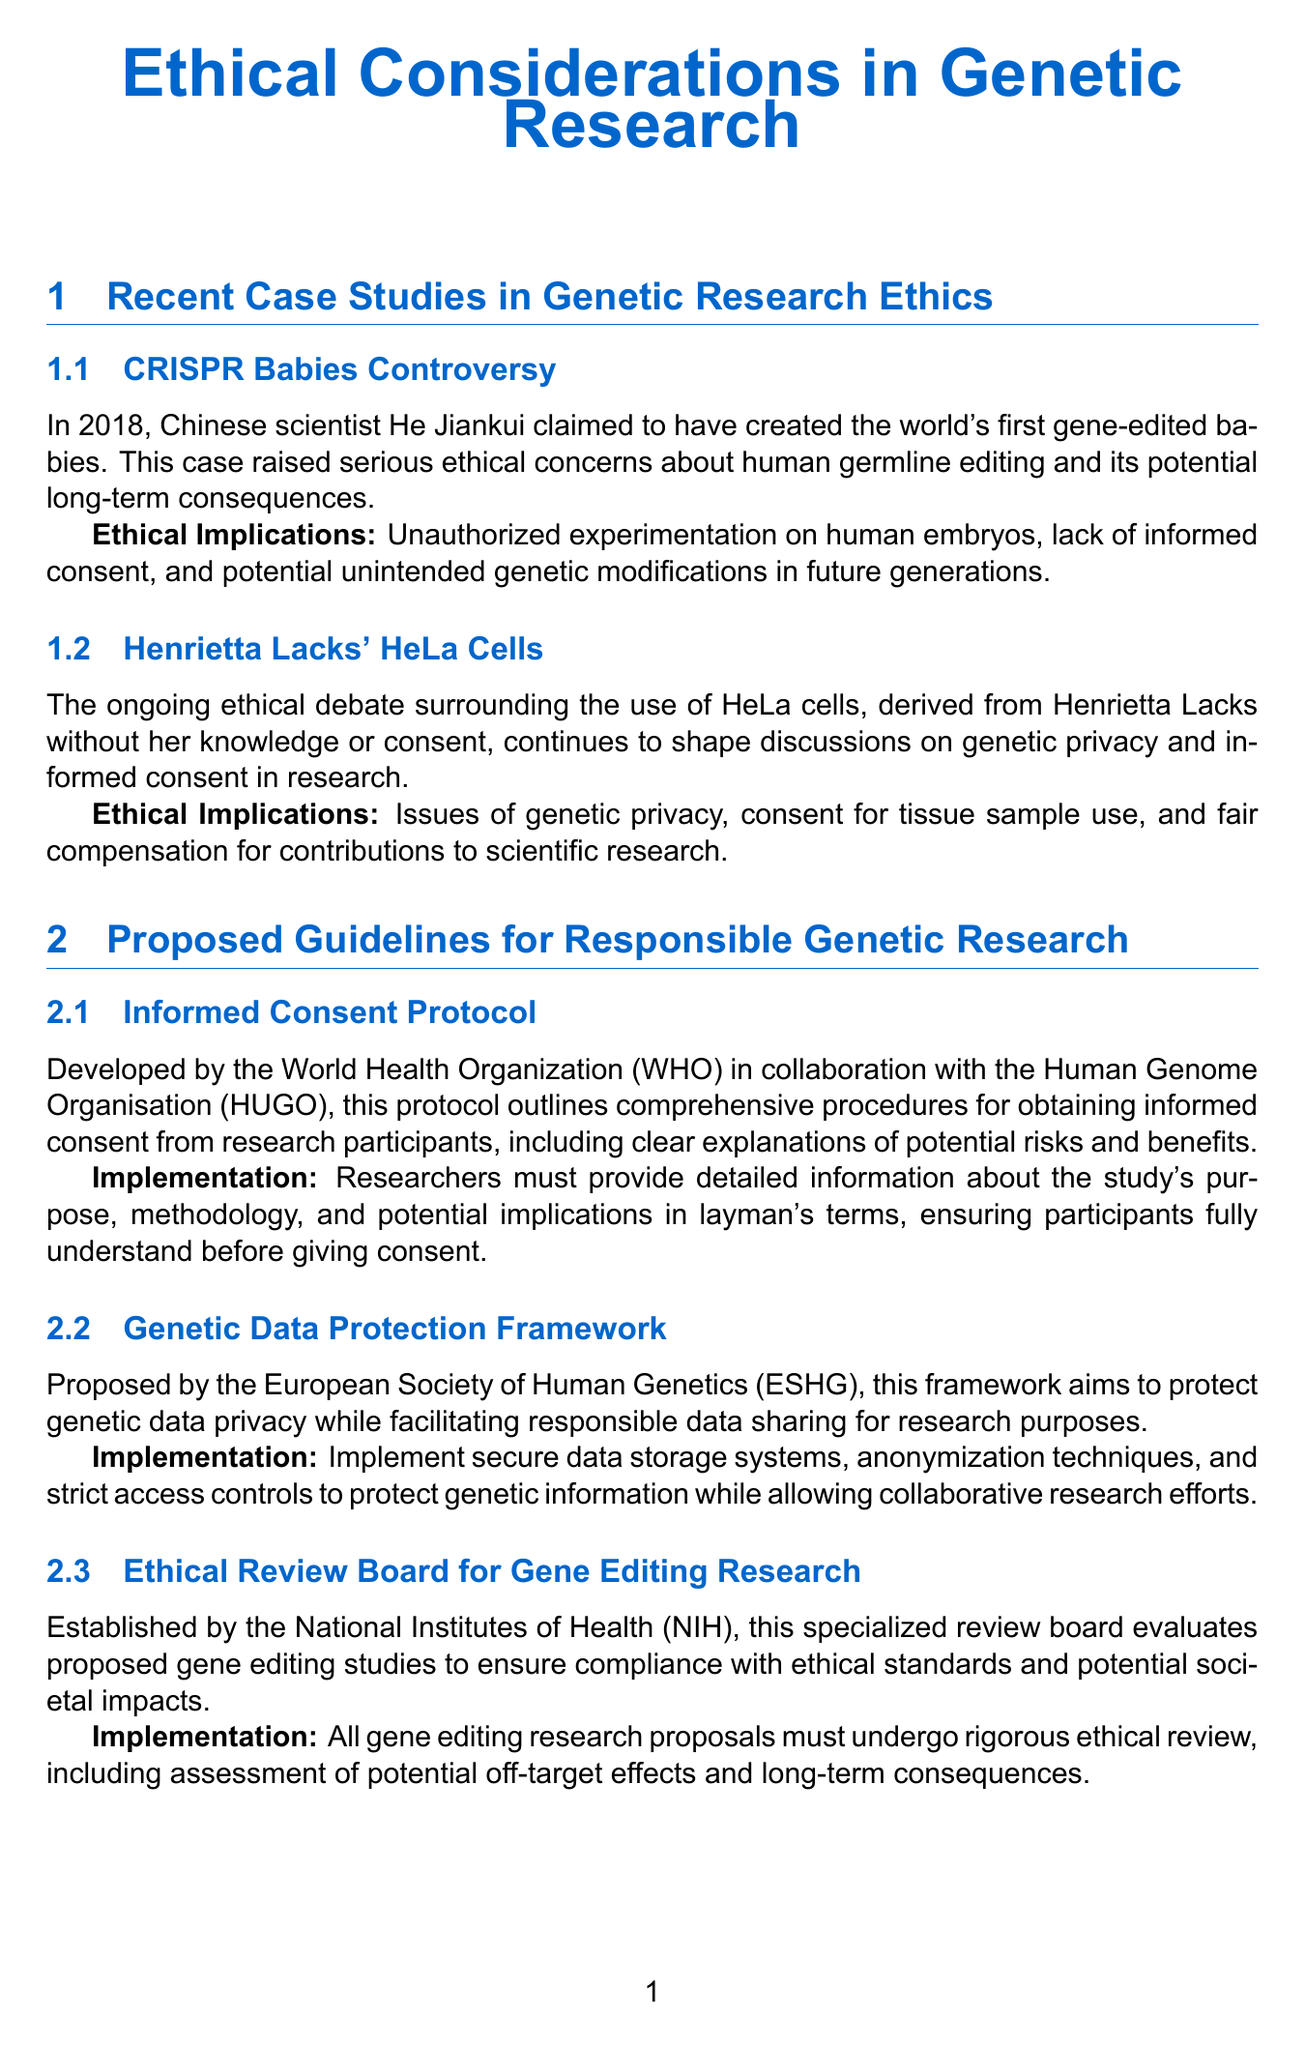What is the title of the newsletter? The title of the newsletter is presented at the beginning, focusing on the ethical considerations in genetic research.
Answer: Ethical Considerations in Genetic Research Who claimed to have created gene-edited babies? The document describes a case where a Chinese scientist made a claim regarding gene-edited babies.
Answer: He Jiankui What ethical implication is associated with the use of HeLa cells? The newsletter outlines various ethical implications regarding the use of HeLa cells, specifically related to privacy and consent.
Answer: Genetic privacy Which organization developed the Informed Consent Protocol? The Informed Consent Protocol is described as having been developed in collaboration with specific organizations.
Answer: World Health Organization (WHO) What is a feature of the EthiCal tool? Several features of the EthiCal software platform are mentioned in the newsletter.
Answer: Automated ethical risk assessment What ethical consideration is related to AI in genetic research? The document discusses various ethical considerations, focusing on a specific aspect of algorithms in genetic research.
Answer: Algorithm transparency What specialized review board was established by the National Institutes of Health? The newsletter details a specialized board for evaluating gene editing studies.
Answer: Ethical Review Board for Gene Editing Research What initiative aims for global harmonization of genetic research standards? The newsletter mentions a consortium formed to address standards in genetic research.
Answer: International Genetic Research Ethics Consortium (IGREC) 